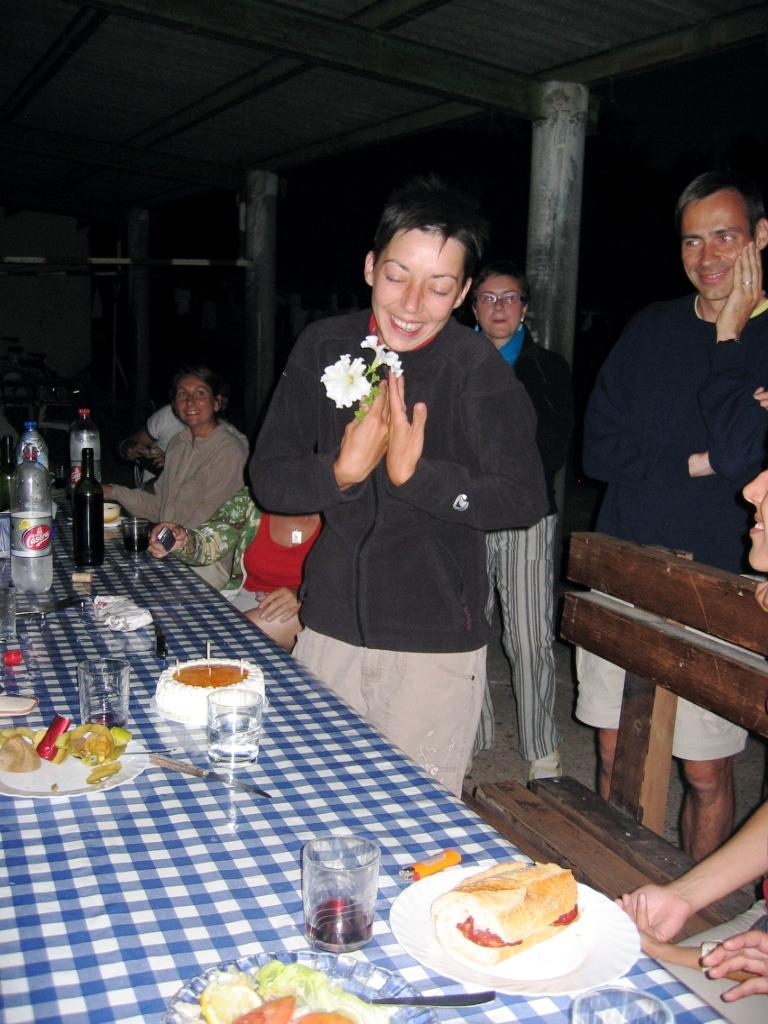What is the main subject of the image? There is a woman in the image. What is the woman doing in the image? The woman is standing and laughing. What can be seen on the dining table in the image? There are plates, food, glasses, and bottles on the dining table. What type of knife is the woman using to kick the grandfather in the image? There is no knife, kicking, or grandfather present in the image. 